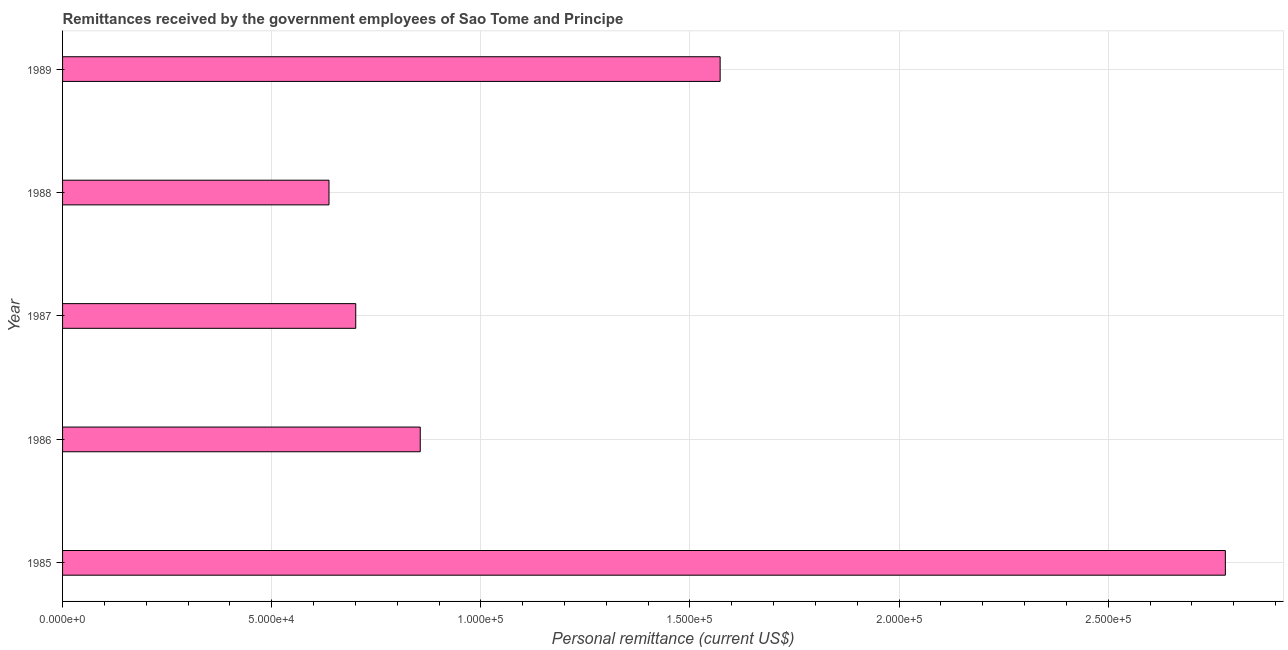Does the graph contain any zero values?
Keep it short and to the point. No. What is the title of the graph?
Offer a terse response. Remittances received by the government employees of Sao Tome and Principe. What is the label or title of the X-axis?
Offer a terse response. Personal remittance (current US$). What is the label or title of the Y-axis?
Give a very brief answer. Year. What is the personal remittances in 1985?
Provide a succinct answer. 2.78e+05. Across all years, what is the maximum personal remittances?
Ensure brevity in your answer.  2.78e+05. Across all years, what is the minimum personal remittances?
Ensure brevity in your answer.  6.37e+04. In which year was the personal remittances maximum?
Give a very brief answer. 1985. In which year was the personal remittances minimum?
Provide a short and direct response. 1988. What is the sum of the personal remittances?
Your answer should be very brief. 6.55e+05. What is the difference between the personal remittances in 1985 and 1987?
Keep it short and to the point. 2.08e+05. What is the average personal remittances per year?
Provide a succinct answer. 1.31e+05. What is the median personal remittances?
Give a very brief answer. 8.55e+04. In how many years, is the personal remittances greater than 180000 US$?
Provide a succinct answer. 1. Do a majority of the years between 1987 and 1985 (inclusive) have personal remittances greater than 250000 US$?
Provide a succinct answer. Yes. What is the ratio of the personal remittances in 1987 to that in 1989?
Ensure brevity in your answer.  0.45. Is the personal remittances in 1987 less than that in 1988?
Your answer should be very brief. No. Is the difference between the personal remittances in 1985 and 1986 greater than the difference between any two years?
Your response must be concise. No. What is the difference between the highest and the second highest personal remittances?
Provide a succinct answer. 1.21e+05. Is the sum of the personal remittances in 1988 and 1989 greater than the maximum personal remittances across all years?
Provide a succinct answer. No. What is the difference between the highest and the lowest personal remittances?
Give a very brief answer. 2.14e+05. Are all the bars in the graph horizontal?
Your answer should be compact. Yes. How many years are there in the graph?
Your answer should be very brief. 5. Are the values on the major ticks of X-axis written in scientific E-notation?
Ensure brevity in your answer.  Yes. What is the Personal remittance (current US$) in 1985?
Offer a terse response. 2.78e+05. What is the Personal remittance (current US$) in 1986?
Give a very brief answer. 8.55e+04. What is the Personal remittance (current US$) in 1987?
Offer a terse response. 7.01e+04. What is the Personal remittance (current US$) of 1988?
Provide a succinct answer. 6.37e+04. What is the Personal remittance (current US$) in 1989?
Your answer should be compact. 1.57e+05. What is the difference between the Personal remittance (current US$) in 1985 and 1986?
Provide a short and direct response. 1.92e+05. What is the difference between the Personal remittance (current US$) in 1985 and 1987?
Your response must be concise. 2.08e+05. What is the difference between the Personal remittance (current US$) in 1985 and 1988?
Ensure brevity in your answer.  2.14e+05. What is the difference between the Personal remittance (current US$) in 1985 and 1989?
Your answer should be very brief. 1.21e+05. What is the difference between the Personal remittance (current US$) in 1986 and 1987?
Provide a short and direct response. 1.54e+04. What is the difference between the Personal remittance (current US$) in 1986 and 1988?
Offer a terse response. 2.18e+04. What is the difference between the Personal remittance (current US$) in 1986 and 1989?
Offer a very short reply. -7.17e+04. What is the difference between the Personal remittance (current US$) in 1987 and 1988?
Give a very brief answer. 6397.01. What is the difference between the Personal remittance (current US$) in 1987 and 1989?
Provide a succinct answer. -8.71e+04. What is the difference between the Personal remittance (current US$) in 1988 and 1989?
Offer a very short reply. -9.35e+04. What is the ratio of the Personal remittance (current US$) in 1985 to that in 1986?
Ensure brevity in your answer.  3.25. What is the ratio of the Personal remittance (current US$) in 1985 to that in 1987?
Offer a very short reply. 3.97. What is the ratio of the Personal remittance (current US$) in 1985 to that in 1988?
Make the answer very short. 4.36. What is the ratio of the Personal remittance (current US$) in 1985 to that in 1989?
Provide a short and direct response. 1.77. What is the ratio of the Personal remittance (current US$) in 1986 to that in 1987?
Offer a very short reply. 1.22. What is the ratio of the Personal remittance (current US$) in 1986 to that in 1988?
Your response must be concise. 1.34. What is the ratio of the Personal remittance (current US$) in 1986 to that in 1989?
Ensure brevity in your answer.  0.54. What is the ratio of the Personal remittance (current US$) in 1987 to that in 1988?
Offer a terse response. 1.1. What is the ratio of the Personal remittance (current US$) in 1987 to that in 1989?
Ensure brevity in your answer.  0.45. What is the ratio of the Personal remittance (current US$) in 1988 to that in 1989?
Keep it short and to the point. 0.41. 